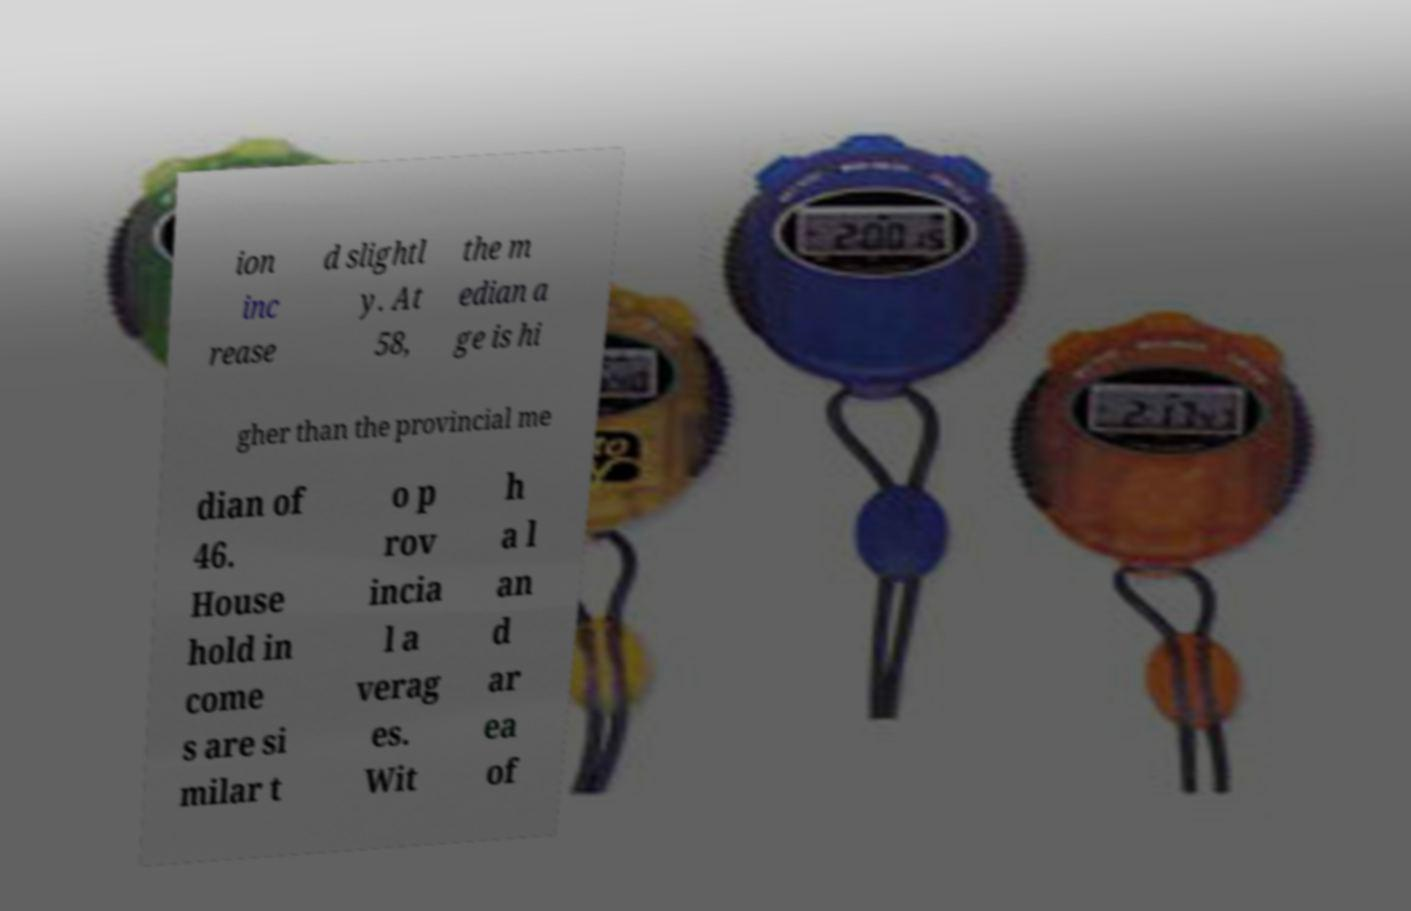For documentation purposes, I need the text within this image transcribed. Could you provide that? ion inc rease d slightl y. At 58, the m edian a ge is hi gher than the provincial me dian of 46. House hold in come s are si milar t o p rov incia l a verag es. Wit h a l an d ar ea of 